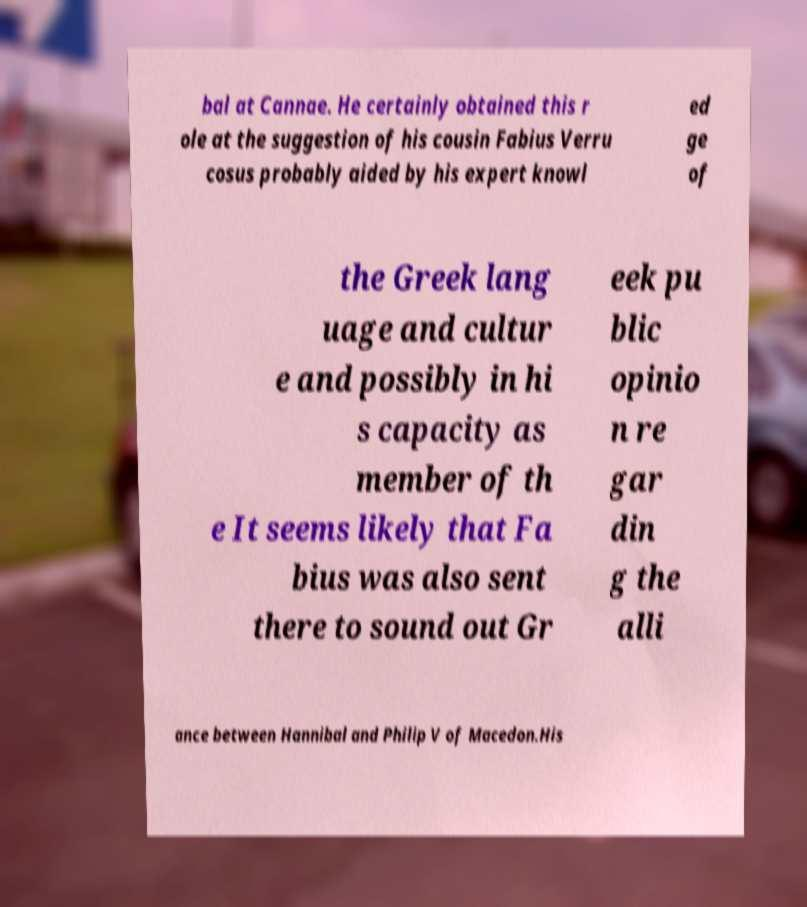I need the written content from this picture converted into text. Can you do that? bal at Cannae. He certainly obtained this r ole at the suggestion of his cousin Fabius Verru cosus probably aided by his expert knowl ed ge of the Greek lang uage and cultur e and possibly in hi s capacity as member of th e It seems likely that Fa bius was also sent there to sound out Gr eek pu blic opinio n re gar din g the alli ance between Hannibal and Philip V of Macedon.His 